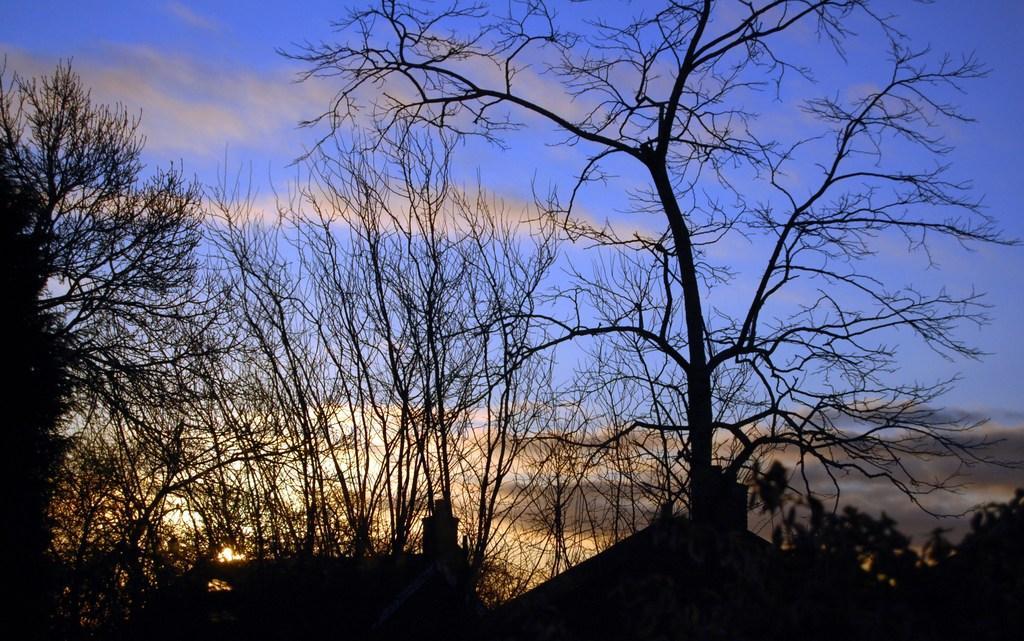How would you summarize this image in a sentence or two? In this image we can see few houses. There are many trees in the image. We can see the clouds in the sky. 